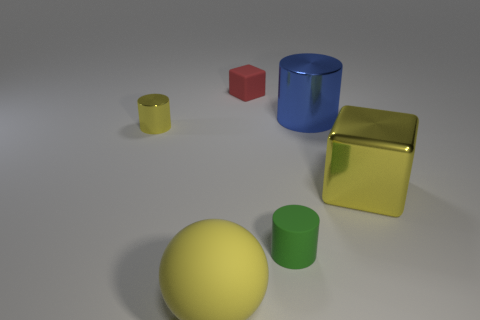Subtract all large cylinders. How many cylinders are left? 2 Subtract all blue cylinders. How many cylinders are left? 2 Subtract all blocks. How many objects are left? 4 Add 2 large purple blocks. How many objects exist? 8 Subtract all large blue metal blocks. Subtract all big cylinders. How many objects are left? 5 Add 2 matte things. How many matte things are left? 5 Add 2 red cylinders. How many red cylinders exist? 2 Subtract 1 yellow cylinders. How many objects are left? 5 Subtract all yellow blocks. Subtract all brown cylinders. How many blocks are left? 1 Subtract all cyan spheres. How many purple cylinders are left? 0 